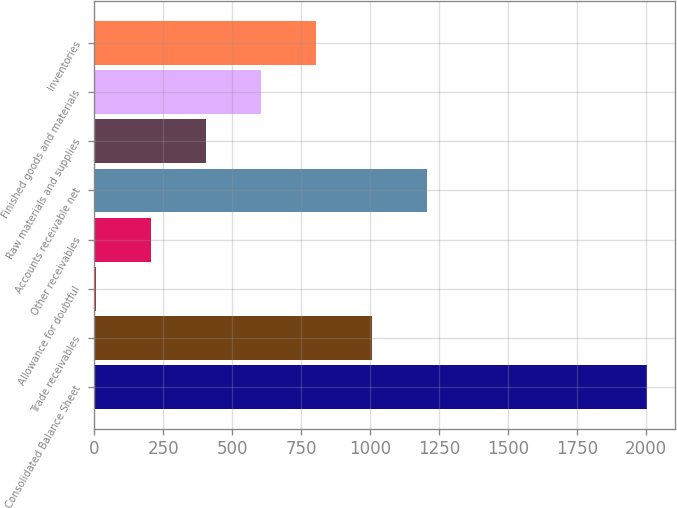Convert chart to OTSL. <chart><loc_0><loc_0><loc_500><loc_500><bar_chart><fcel>Consolidated Balance Sheet<fcel>Trade receivables<fcel>Allowance for doubtful<fcel>Other receivables<fcel>Accounts receivable net<fcel>Raw materials and supplies<fcel>Finished goods and materials<fcel>Inventories<nl><fcel>2005<fcel>1005.95<fcel>6.9<fcel>206.71<fcel>1205.76<fcel>406.52<fcel>606.33<fcel>806.14<nl></chart> 